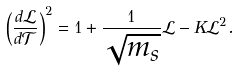Convert formula to latex. <formula><loc_0><loc_0><loc_500><loc_500>\left ( \frac { d \mathcal { L } } { d \mathcal { T } } \right ) ^ { 2 } = 1 + \frac { 1 } { \sqrt { m _ { s } } } \mathcal { L } - K \mathcal { L } ^ { 2 } .</formula> 